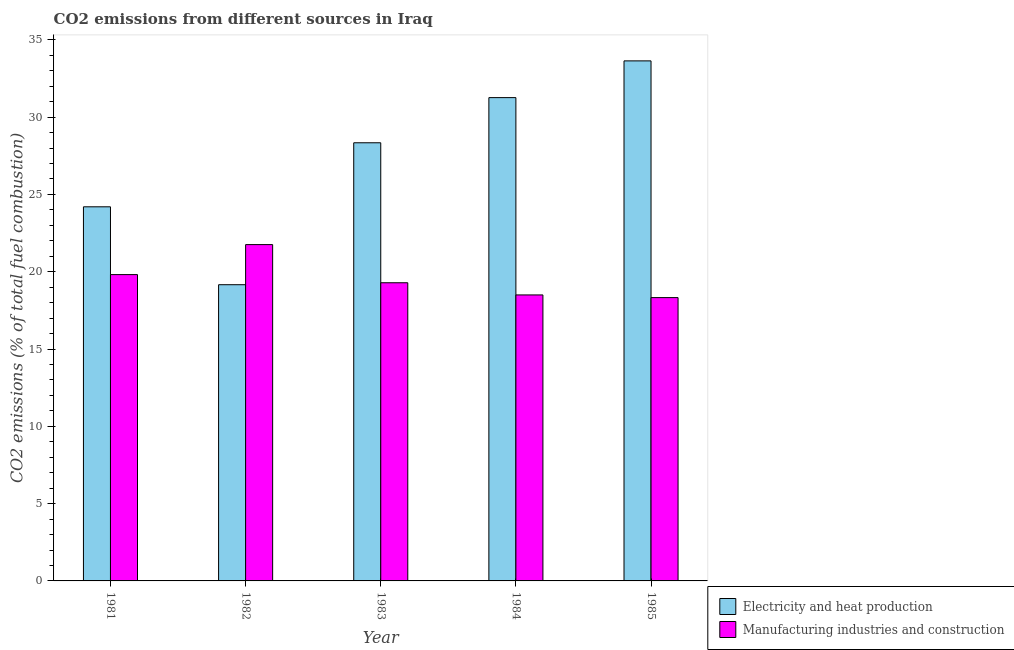How many groups of bars are there?
Your answer should be very brief. 5. Are the number of bars per tick equal to the number of legend labels?
Offer a very short reply. Yes. In how many cases, is the number of bars for a given year not equal to the number of legend labels?
Provide a succinct answer. 0. What is the co2 emissions due to manufacturing industries in 1981?
Provide a succinct answer. 19.82. Across all years, what is the maximum co2 emissions due to manufacturing industries?
Provide a succinct answer. 21.76. Across all years, what is the minimum co2 emissions due to electricity and heat production?
Keep it short and to the point. 19.16. In which year was the co2 emissions due to electricity and heat production minimum?
Offer a very short reply. 1982. What is the total co2 emissions due to electricity and heat production in the graph?
Offer a very short reply. 136.61. What is the difference between the co2 emissions due to electricity and heat production in 1981 and that in 1983?
Provide a short and direct response. -4.14. What is the difference between the co2 emissions due to manufacturing industries in 1982 and the co2 emissions due to electricity and heat production in 1983?
Make the answer very short. 2.47. What is the average co2 emissions due to manufacturing industries per year?
Give a very brief answer. 19.54. In the year 1981, what is the difference between the co2 emissions due to electricity and heat production and co2 emissions due to manufacturing industries?
Provide a short and direct response. 0. In how many years, is the co2 emissions due to electricity and heat production greater than 4 %?
Offer a very short reply. 5. What is the ratio of the co2 emissions due to manufacturing industries in 1982 to that in 1983?
Give a very brief answer. 1.13. Is the co2 emissions due to manufacturing industries in 1981 less than that in 1985?
Ensure brevity in your answer.  No. Is the difference between the co2 emissions due to manufacturing industries in 1981 and 1982 greater than the difference between the co2 emissions due to electricity and heat production in 1981 and 1982?
Provide a succinct answer. No. What is the difference between the highest and the second highest co2 emissions due to manufacturing industries?
Keep it short and to the point. 1.94. What is the difference between the highest and the lowest co2 emissions due to manufacturing industries?
Keep it short and to the point. 3.43. In how many years, is the co2 emissions due to manufacturing industries greater than the average co2 emissions due to manufacturing industries taken over all years?
Keep it short and to the point. 2. Is the sum of the co2 emissions due to manufacturing industries in 1983 and 1985 greater than the maximum co2 emissions due to electricity and heat production across all years?
Provide a succinct answer. Yes. What does the 2nd bar from the left in 1981 represents?
Your answer should be very brief. Manufacturing industries and construction. What does the 1st bar from the right in 1981 represents?
Keep it short and to the point. Manufacturing industries and construction. How many bars are there?
Your answer should be very brief. 10. Are the values on the major ticks of Y-axis written in scientific E-notation?
Keep it short and to the point. No. Does the graph contain grids?
Offer a terse response. No. How many legend labels are there?
Provide a succinct answer. 2. What is the title of the graph?
Your answer should be very brief. CO2 emissions from different sources in Iraq. What is the label or title of the Y-axis?
Make the answer very short. CO2 emissions (% of total fuel combustion). What is the CO2 emissions (% of total fuel combustion) of Electricity and heat production in 1981?
Offer a terse response. 24.2. What is the CO2 emissions (% of total fuel combustion) in Manufacturing industries and construction in 1981?
Provide a succinct answer. 19.82. What is the CO2 emissions (% of total fuel combustion) of Electricity and heat production in 1982?
Offer a very short reply. 19.16. What is the CO2 emissions (% of total fuel combustion) in Manufacturing industries and construction in 1982?
Your answer should be very brief. 21.76. What is the CO2 emissions (% of total fuel combustion) of Electricity and heat production in 1983?
Your answer should be very brief. 28.34. What is the CO2 emissions (% of total fuel combustion) in Manufacturing industries and construction in 1983?
Make the answer very short. 19.29. What is the CO2 emissions (% of total fuel combustion) in Electricity and heat production in 1984?
Ensure brevity in your answer.  31.26. What is the CO2 emissions (% of total fuel combustion) in Manufacturing industries and construction in 1984?
Your response must be concise. 18.5. What is the CO2 emissions (% of total fuel combustion) in Electricity and heat production in 1985?
Provide a succinct answer. 33.64. What is the CO2 emissions (% of total fuel combustion) of Manufacturing industries and construction in 1985?
Keep it short and to the point. 18.33. Across all years, what is the maximum CO2 emissions (% of total fuel combustion) in Electricity and heat production?
Provide a short and direct response. 33.64. Across all years, what is the maximum CO2 emissions (% of total fuel combustion) of Manufacturing industries and construction?
Give a very brief answer. 21.76. Across all years, what is the minimum CO2 emissions (% of total fuel combustion) of Electricity and heat production?
Keep it short and to the point. 19.16. Across all years, what is the minimum CO2 emissions (% of total fuel combustion) in Manufacturing industries and construction?
Your response must be concise. 18.33. What is the total CO2 emissions (% of total fuel combustion) in Electricity and heat production in the graph?
Offer a very short reply. 136.61. What is the total CO2 emissions (% of total fuel combustion) of Manufacturing industries and construction in the graph?
Your answer should be compact. 97.69. What is the difference between the CO2 emissions (% of total fuel combustion) of Electricity and heat production in 1981 and that in 1982?
Offer a terse response. 5.04. What is the difference between the CO2 emissions (% of total fuel combustion) in Manufacturing industries and construction in 1981 and that in 1982?
Your answer should be very brief. -1.94. What is the difference between the CO2 emissions (% of total fuel combustion) in Electricity and heat production in 1981 and that in 1983?
Ensure brevity in your answer.  -4.14. What is the difference between the CO2 emissions (% of total fuel combustion) of Manufacturing industries and construction in 1981 and that in 1983?
Make the answer very short. 0.53. What is the difference between the CO2 emissions (% of total fuel combustion) in Electricity and heat production in 1981 and that in 1984?
Provide a succinct answer. -7.06. What is the difference between the CO2 emissions (% of total fuel combustion) in Manufacturing industries and construction in 1981 and that in 1984?
Your answer should be very brief. 1.32. What is the difference between the CO2 emissions (% of total fuel combustion) of Electricity and heat production in 1981 and that in 1985?
Ensure brevity in your answer.  -9.44. What is the difference between the CO2 emissions (% of total fuel combustion) of Manufacturing industries and construction in 1981 and that in 1985?
Provide a succinct answer. 1.49. What is the difference between the CO2 emissions (% of total fuel combustion) of Electricity and heat production in 1982 and that in 1983?
Make the answer very short. -9.18. What is the difference between the CO2 emissions (% of total fuel combustion) in Manufacturing industries and construction in 1982 and that in 1983?
Your answer should be compact. 2.47. What is the difference between the CO2 emissions (% of total fuel combustion) in Electricity and heat production in 1982 and that in 1984?
Offer a very short reply. -12.1. What is the difference between the CO2 emissions (% of total fuel combustion) of Manufacturing industries and construction in 1982 and that in 1984?
Your response must be concise. 3.26. What is the difference between the CO2 emissions (% of total fuel combustion) in Electricity and heat production in 1982 and that in 1985?
Offer a terse response. -14.48. What is the difference between the CO2 emissions (% of total fuel combustion) in Manufacturing industries and construction in 1982 and that in 1985?
Make the answer very short. 3.43. What is the difference between the CO2 emissions (% of total fuel combustion) of Electricity and heat production in 1983 and that in 1984?
Your response must be concise. -2.92. What is the difference between the CO2 emissions (% of total fuel combustion) in Manufacturing industries and construction in 1983 and that in 1984?
Your answer should be compact. 0.79. What is the difference between the CO2 emissions (% of total fuel combustion) of Electricity and heat production in 1983 and that in 1985?
Provide a succinct answer. -5.3. What is the difference between the CO2 emissions (% of total fuel combustion) of Manufacturing industries and construction in 1983 and that in 1985?
Make the answer very short. 0.96. What is the difference between the CO2 emissions (% of total fuel combustion) of Electricity and heat production in 1984 and that in 1985?
Make the answer very short. -2.38. What is the difference between the CO2 emissions (% of total fuel combustion) in Manufacturing industries and construction in 1984 and that in 1985?
Your response must be concise. 0.17. What is the difference between the CO2 emissions (% of total fuel combustion) of Electricity and heat production in 1981 and the CO2 emissions (% of total fuel combustion) of Manufacturing industries and construction in 1982?
Your response must be concise. 2.45. What is the difference between the CO2 emissions (% of total fuel combustion) of Electricity and heat production in 1981 and the CO2 emissions (% of total fuel combustion) of Manufacturing industries and construction in 1983?
Offer a terse response. 4.91. What is the difference between the CO2 emissions (% of total fuel combustion) in Electricity and heat production in 1981 and the CO2 emissions (% of total fuel combustion) in Manufacturing industries and construction in 1984?
Provide a succinct answer. 5.7. What is the difference between the CO2 emissions (% of total fuel combustion) of Electricity and heat production in 1981 and the CO2 emissions (% of total fuel combustion) of Manufacturing industries and construction in 1985?
Your answer should be compact. 5.87. What is the difference between the CO2 emissions (% of total fuel combustion) of Electricity and heat production in 1982 and the CO2 emissions (% of total fuel combustion) of Manufacturing industries and construction in 1983?
Your answer should be compact. -0.13. What is the difference between the CO2 emissions (% of total fuel combustion) in Electricity and heat production in 1982 and the CO2 emissions (% of total fuel combustion) in Manufacturing industries and construction in 1984?
Keep it short and to the point. 0.66. What is the difference between the CO2 emissions (% of total fuel combustion) in Electricity and heat production in 1982 and the CO2 emissions (% of total fuel combustion) in Manufacturing industries and construction in 1985?
Offer a terse response. 0.83. What is the difference between the CO2 emissions (% of total fuel combustion) of Electricity and heat production in 1983 and the CO2 emissions (% of total fuel combustion) of Manufacturing industries and construction in 1984?
Offer a terse response. 9.84. What is the difference between the CO2 emissions (% of total fuel combustion) in Electricity and heat production in 1983 and the CO2 emissions (% of total fuel combustion) in Manufacturing industries and construction in 1985?
Keep it short and to the point. 10.02. What is the difference between the CO2 emissions (% of total fuel combustion) of Electricity and heat production in 1984 and the CO2 emissions (% of total fuel combustion) of Manufacturing industries and construction in 1985?
Provide a short and direct response. 12.94. What is the average CO2 emissions (% of total fuel combustion) of Electricity and heat production per year?
Your answer should be very brief. 27.32. What is the average CO2 emissions (% of total fuel combustion) of Manufacturing industries and construction per year?
Provide a succinct answer. 19.54. In the year 1981, what is the difference between the CO2 emissions (% of total fuel combustion) of Electricity and heat production and CO2 emissions (% of total fuel combustion) of Manufacturing industries and construction?
Keep it short and to the point. 4.39. In the year 1982, what is the difference between the CO2 emissions (% of total fuel combustion) of Electricity and heat production and CO2 emissions (% of total fuel combustion) of Manufacturing industries and construction?
Ensure brevity in your answer.  -2.6. In the year 1983, what is the difference between the CO2 emissions (% of total fuel combustion) in Electricity and heat production and CO2 emissions (% of total fuel combustion) in Manufacturing industries and construction?
Make the answer very short. 9.06. In the year 1984, what is the difference between the CO2 emissions (% of total fuel combustion) in Electricity and heat production and CO2 emissions (% of total fuel combustion) in Manufacturing industries and construction?
Give a very brief answer. 12.76. In the year 1985, what is the difference between the CO2 emissions (% of total fuel combustion) of Electricity and heat production and CO2 emissions (% of total fuel combustion) of Manufacturing industries and construction?
Make the answer very short. 15.31. What is the ratio of the CO2 emissions (% of total fuel combustion) of Electricity and heat production in 1981 to that in 1982?
Your answer should be compact. 1.26. What is the ratio of the CO2 emissions (% of total fuel combustion) of Manufacturing industries and construction in 1981 to that in 1982?
Ensure brevity in your answer.  0.91. What is the ratio of the CO2 emissions (% of total fuel combustion) of Electricity and heat production in 1981 to that in 1983?
Provide a succinct answer. 0.85. What is the ratio of the CO2 emissions (% of total fuel combustion) of Manufacturing industries and construction in 1981 to that in 1983?
Give a very brief answer. 1.03. What is the ratio of the CO2 emissions (% of total fuel combustion) of Electricity and heat production in 1981 to that in 1984?
Provide a succinct answer. 0.77. What is the ratio of the CO2 emissions (% of total fuel combustion) of Manufacturing industries and construction in 1981 to that in 1984?
Keep it short and to the point. 1.07. What is the ratio of the CO2 emissions (% of total fuel combustion) of Electricity and heat production in 1981 to that in 1985?
Give a very brief answer. 0.72. What is the ratio of the CO2 emissions (% of total fuel combustion) of Manufacturing industries and construction in 1981 to that in 1985?
Your answer should be compact. 1.08. What is the ratio of the CO2 emissions (% of total fuel combustion) in Electricity and heat production in 1982 to that in 1983?
Your response must be concise. 0.68. What is the ratio of the CO2 emissions (% of total fuel combustion) in Manufacturing industries and construction in 1982 to that in 1983?
Your response must be concise. 1.13. What is the ratio of the CO2 emissions (% of total fuel combustion) in Electricity and heat production in 1982 to that in 1984?
Your answer should be compact. 0.61. What is the ratio of the CO2 emissions (% of total fuel combustion) in Manufacturing industries and construction in 1982 to that in 1984?
Ensure brevity in your answer.  1.18. What is the ratio of the CO2 emissions (% of total fuel combustion) in Electricity and heat production in 1982 to that in 1985?
Offer a terse response. 0.57. What is the ratio of the CO2 emissions (% of total fuel combustion) in Manufacturing industries and construction in 1982 to that in 1985?
Ensure brevity in your answer.  1.19. What is the ratio of the CO2 emissions (% of total fuel combustion) in Electricity and heat production in 1983 to that in 1984?
Your answer should be very brief. 0.91. What is the ratio of the CO2 emissions (% of total fuel combustion) in Manufacturing industries and construction in 1983 to that in 1984?
Offer a very short reply. 1.04. What is the ratio of the CO2 emissions (% of total fuel combustion) in Electricity and heat production in 1983 to that in 1985?
Your answer should be very brief. 0.84. What is the ratio of the CO2 emissions (% of total fuel combustion) in Manufacturing industries and construction in 1983 to that in 1985?
Keep it short and to the point. 1.05. What is the ratio of the CO2 emissions (% of total fuel combustion) in Electricity and heat production in 1984 to that in 1985?
Provide a succinct answer. 0.93. What is the ratio of the CO2 emissions (% of total fuel combustion) in Manufacturing industries and construction in 1984 to that in 1985?
Make the answer very short. 1.01. What is the difference between the highest and the second highest CO2 emissions (% of total fuel combustion) of Electricity and heat production?
Offer a terse response. 2.38. What is the difference between the highest and the second highest CO2 emissions (% of total fuel combustion) of Manufacturing industries and construction?
Your response must be concise. 1.94. What is the difference between the highest and the lowest CO2 emissions (% of total fuel combustion) of Electricity and heat production?
Make the answer very short. 14.48. What is the difference between the highest and the lowest CO2 emissions (% of total fuel combustion) of Manufacturing industries and construction?
Keep it short and to the point. 3.43. 